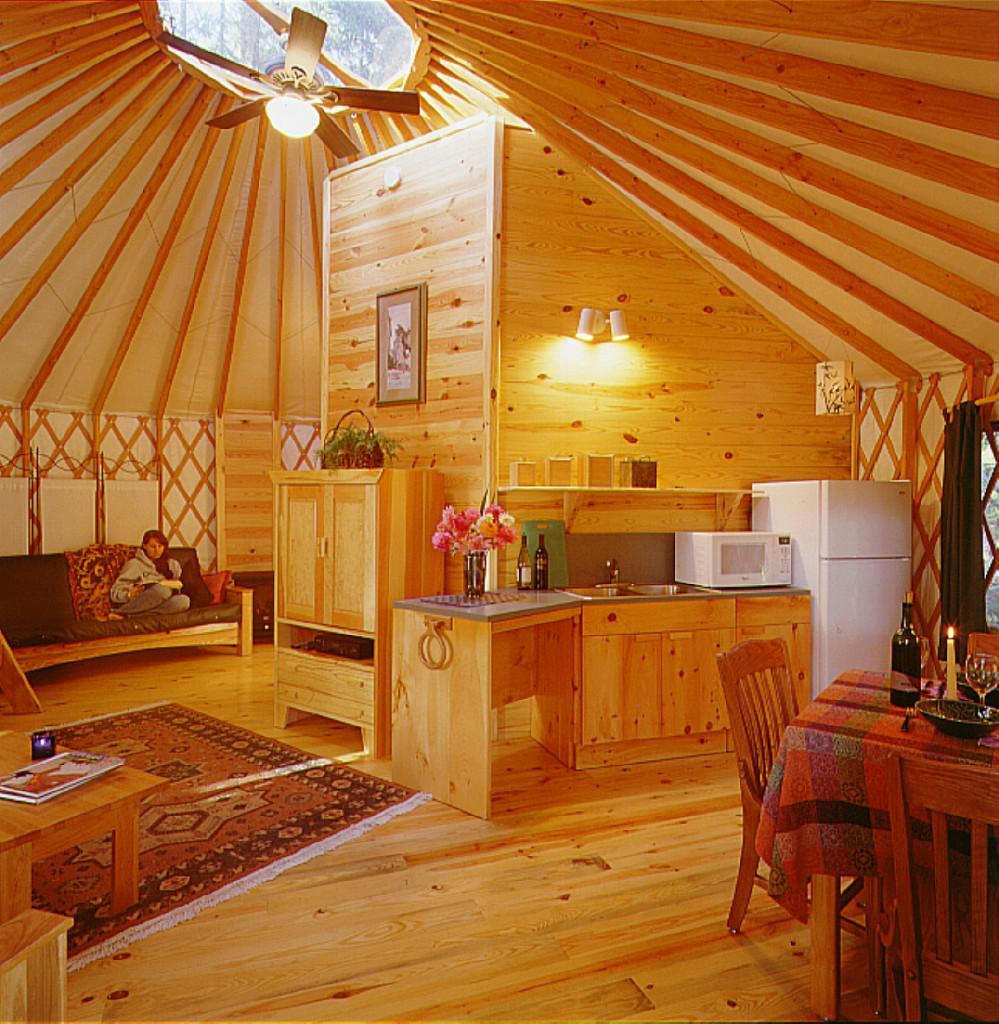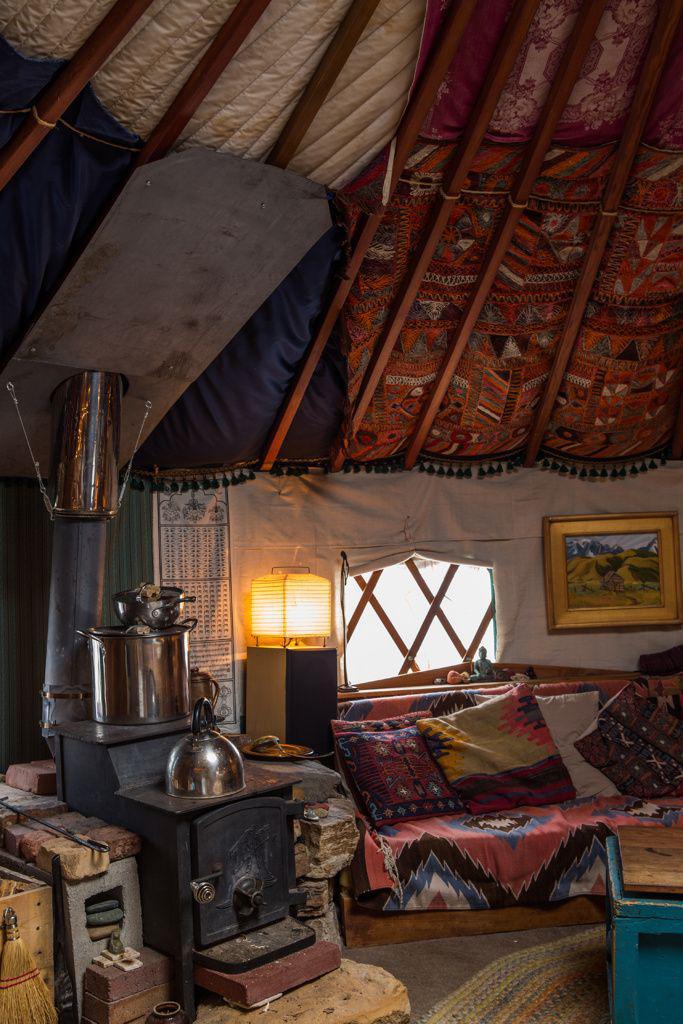The first image is the image on the left, the second image is the image on the right. For the images shown, is this caption "An image shows a sky-light type many-sided element at the peak of a room's ceiling." true? Answer yes or no. Yes. The first image is the image on the left, the second image is the image on the right. For the images shown, is this caption "One image shows the kitchen of a yurt with white refrigerator and microwave and a vase of flowers near a dining seating area with wooden kitchen chairs." true? Answer yes or no. Yes. The first image is the image on the left, the second image is the image on the right. For the images shown, is this caption "One image shows the kitchen of a yurt with white refrigerator and microwave, near a dining seating area with wooden kitchen chairs." true? Answer yes or no. Yes. The first image is the image on the left, the second image is the image on the right. Analyze the images presented: Is the assertion "A ceiling fan is hanging above a kitchen in the left image." valid? Answer yes or no. Yes. 